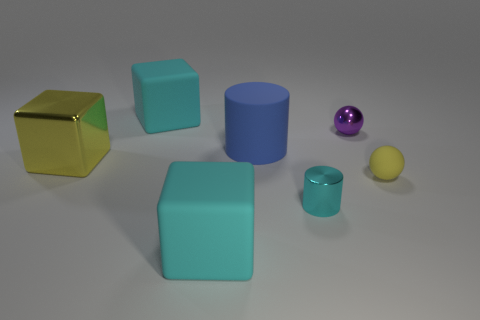What number of blue rubber cylinders are on the left side of the purple metal object?
Offer a terse response. 1. What number of other objects are the same color as the large rubber cylinder?
Provide a succinct answer. 0. Is the number of small rubber balls behind the big cylinder less than the number of tiny yellow things behind the large yellow metallic object?
Your response must be concise. No. How many things are small balls that are behind the large blue cylinder or cyan shiny cylinders?
Ensure brevity in your answer.  2. Is the size of the purple metallic sphere the same as the cylinder in front of the yellow block?
Offer a very short reply. Yes. There is another object that is the same shape as the tiny cyan metal thing; what is its size?
Offer a very short reply. Large. There is a large cyan object that is behind the block that is in front of the big metallic object; how many things are to the left of it?
Your answer should be very brief. 1. What number of spheres are either cyan matte things or purple objects?
Your response must be concise. 1. What color is the large cube that is right of the large cyan thing left of the cyan cube that is in front of the large blue cylinder?
Offer a very short reply. Cyan. What number of other objects are the same size as the yellow rubber thing?
Offer a very short reply. 2. 